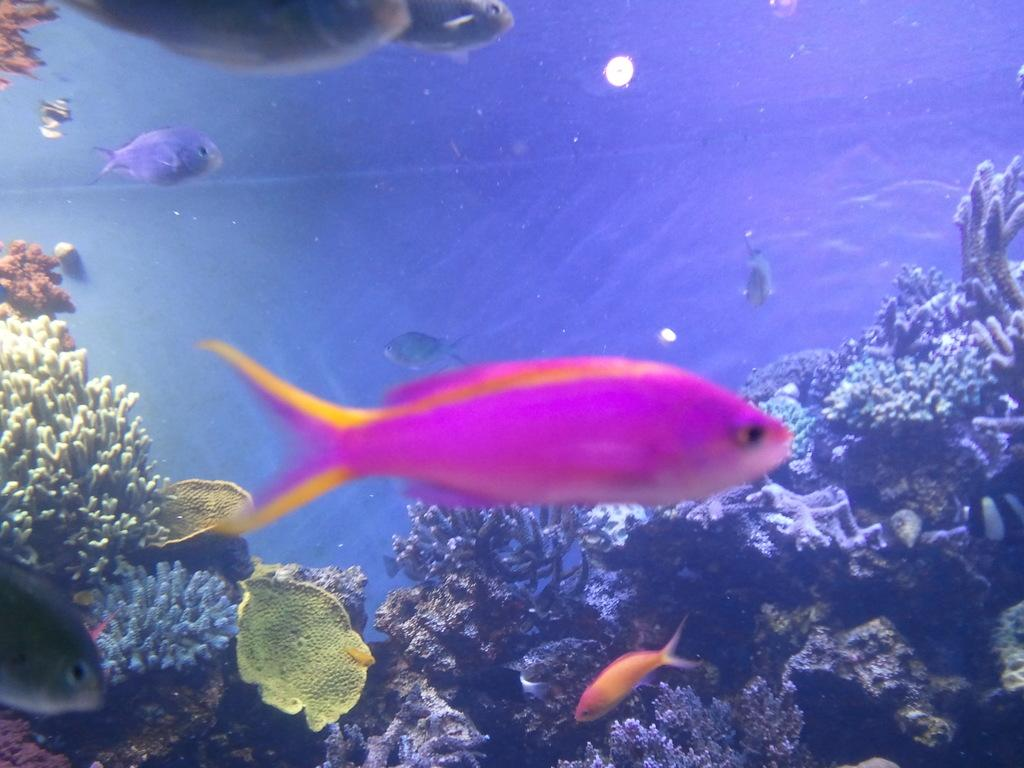What type of animals can be seen in the image? There are fishes in the water. What other elements can be seen in the water besides the fishes? There are water plants in the image. What type of underwater structure is visible in the image? There is a coral reef in the image. What type of cracker is being used to feed the fishes in the image? There is no cracker present in the image, as it features fishes in the water with water plants and a coral reef. 